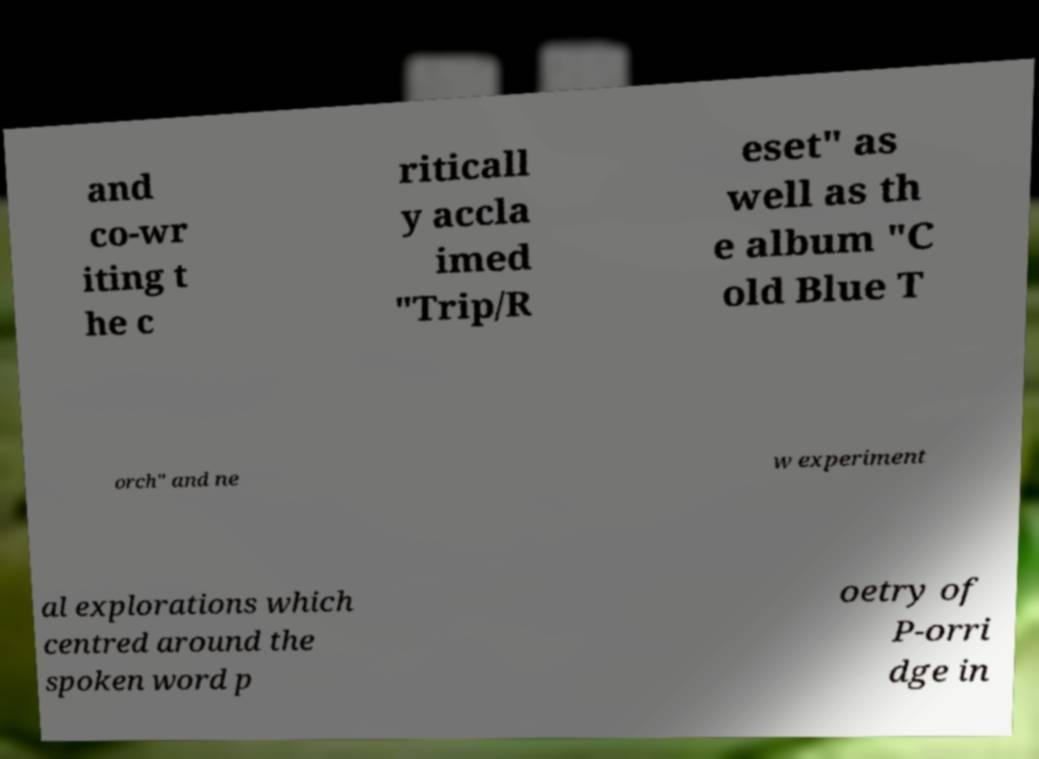Please read and relay the text visible in this image. What does it say? and co-wr iting t he c riticall y accla imed "Trip/R eset" as well as th e album "C old Blue T orch" and ne w experiment al explorations which centred around the spoken word p oetry of P-orri dge in 